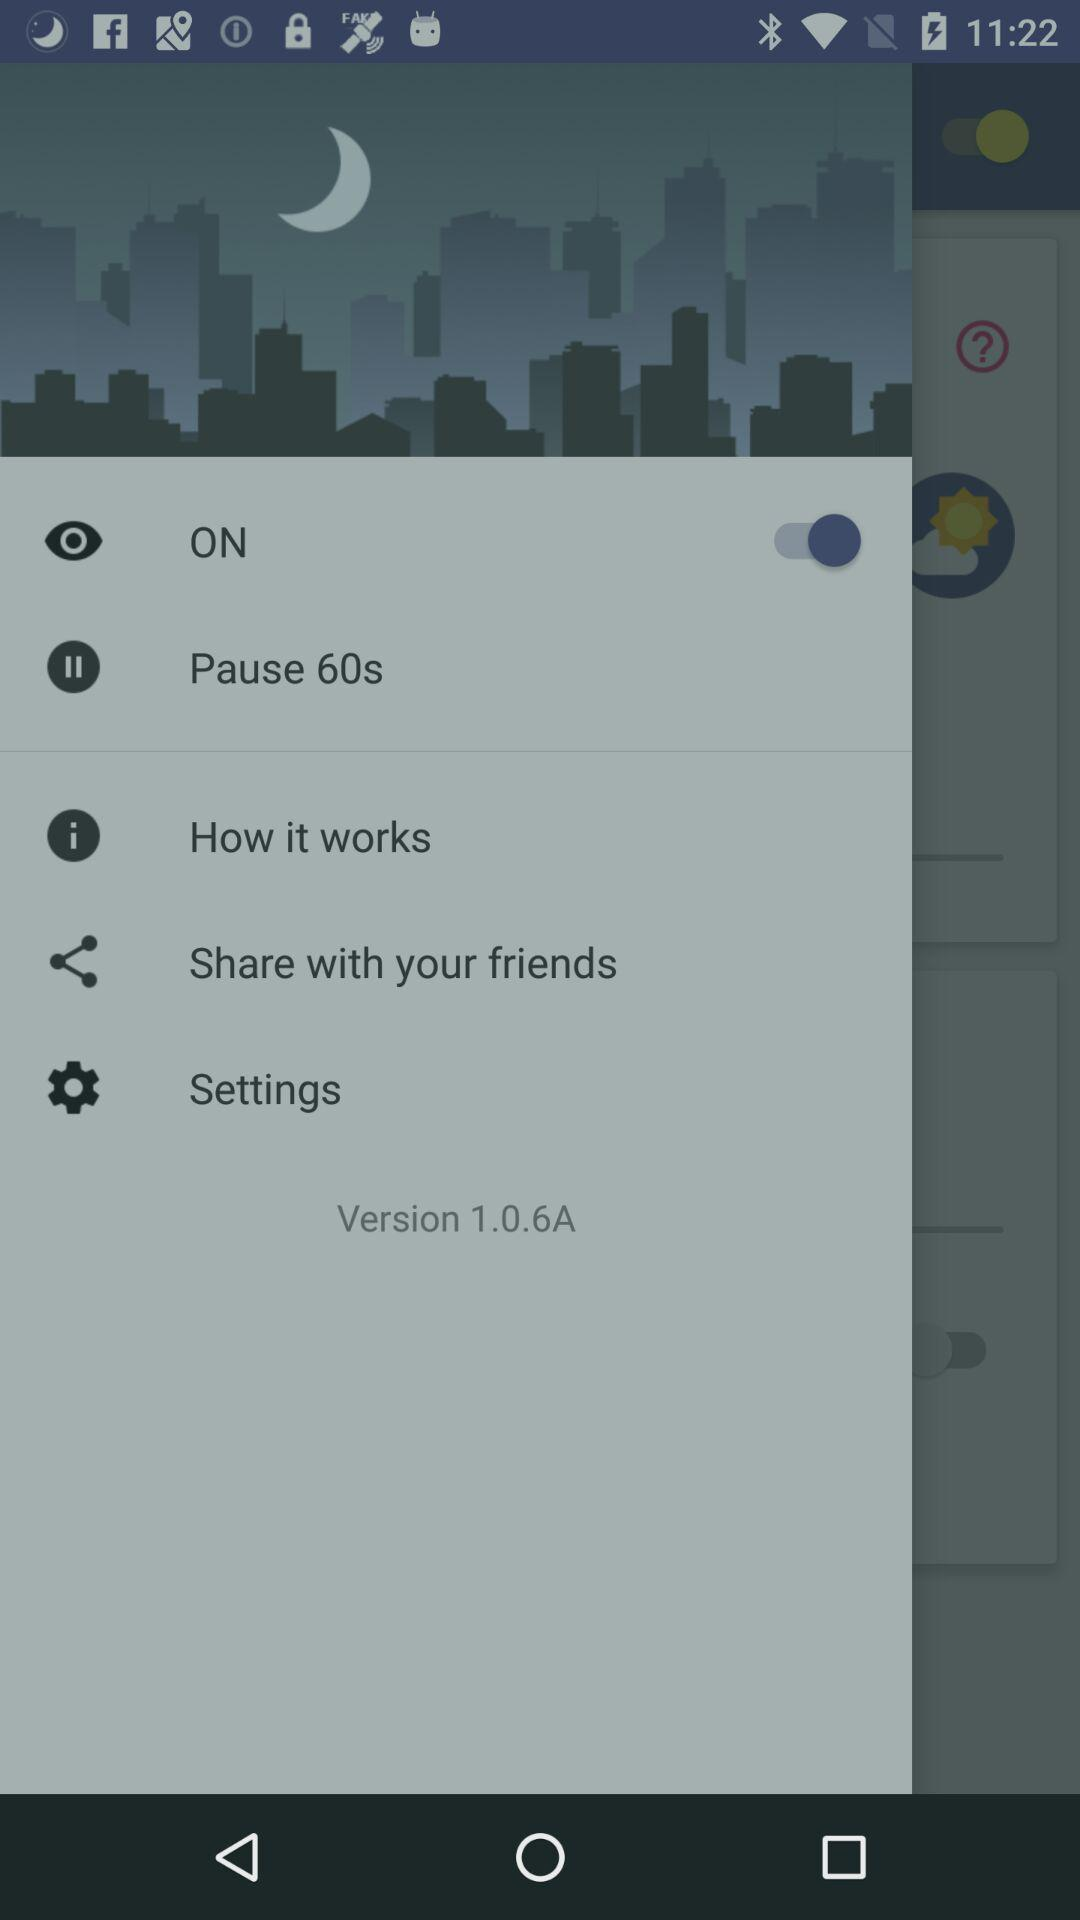What is the pause time?
When the provided information is insufficient, respond with <no answer>. <no answer> 